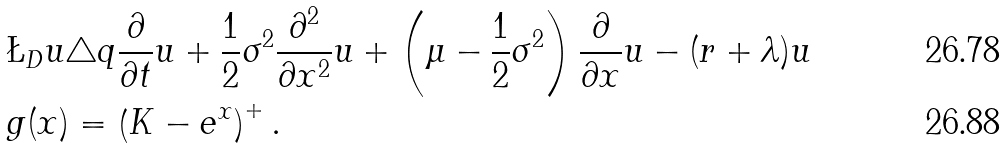Convert formula to latex. <formula><loc_0><loc_0><loc_500><loc_500>& \L _ { D } u \triangle q \frac { \partial } { \partial t } u + \frac { 1 } { 2 } \sigma ^ { 2 } \frac { \partial ^ { 2 } } { \partial x ^ { 2 } } u + \left ( \mu - \frac { 1 } { 2 } \sigma ^ { 2 } \right ) \frac { \partial } { \partial x } u - ( r + \lambda ) u \\ & g ( x ) = \left ( K - e ^ { x } \right ) ^ { + } .</formula> 